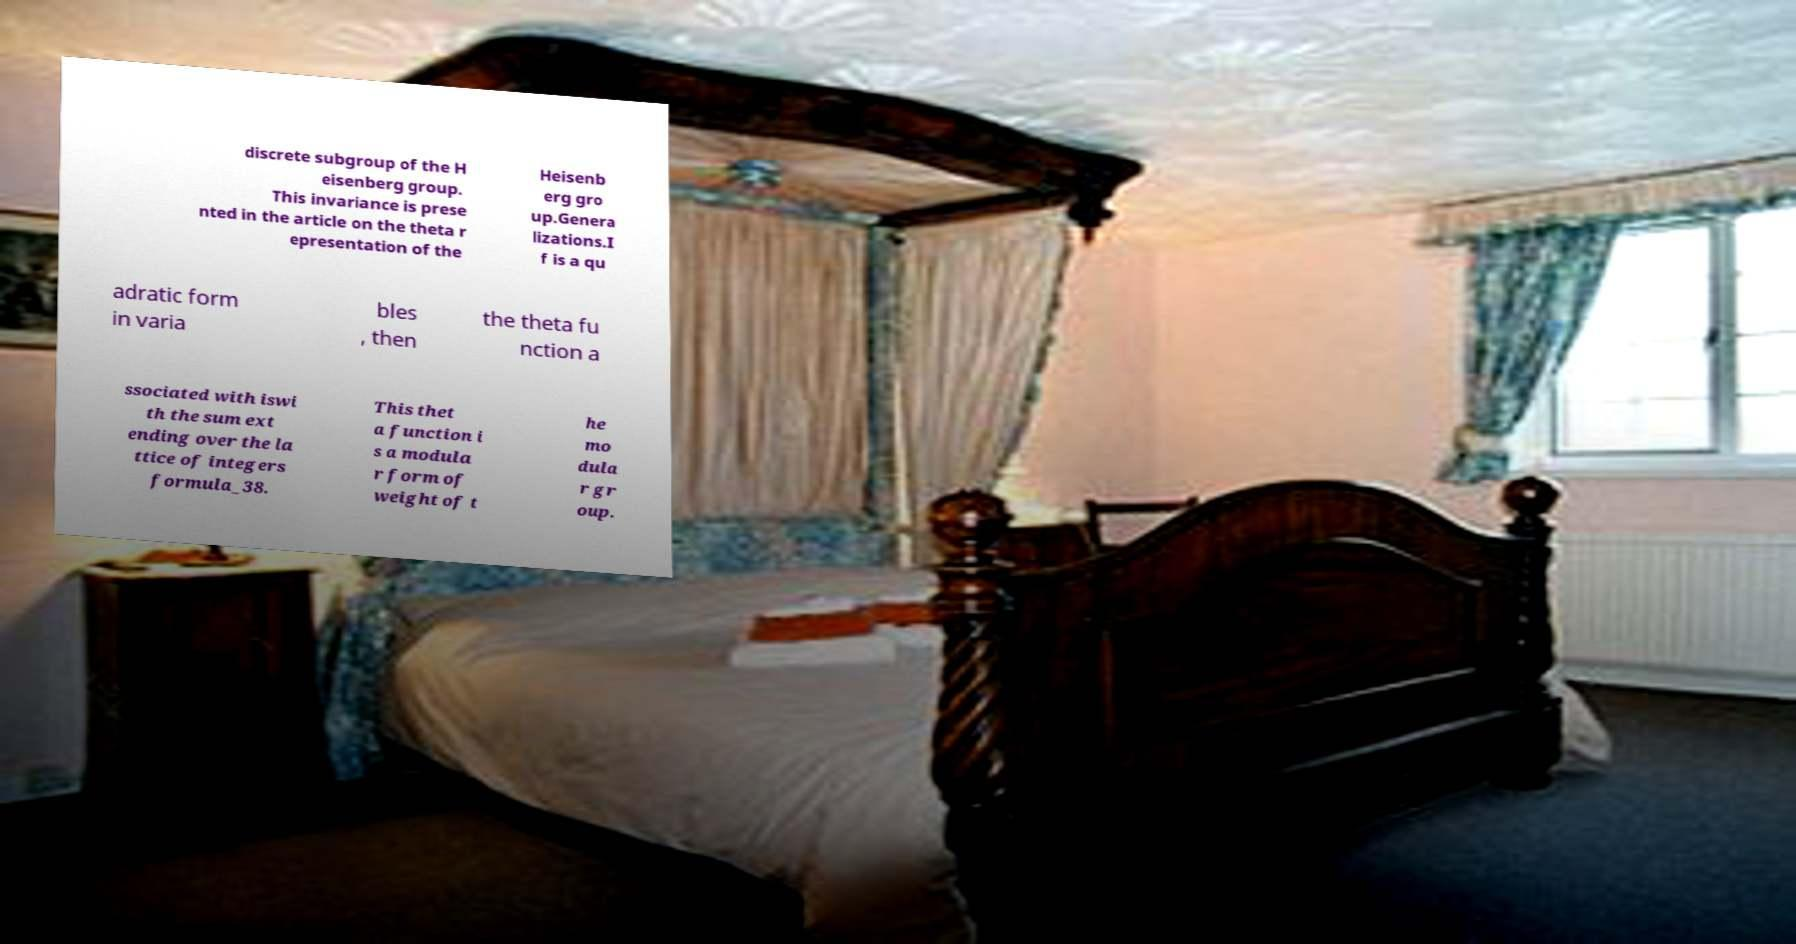Please identify and transcribe the text found in this image. discrete subgroup of the H eisenberg group. This invariance is prese nted in the article on the theta r epresentation of the Heisenb erg gro up.Genera lizations.I f is a qu adratic form in varia bles , then the theta fu nction a ssociated with iswi th the sum ext ending over the la ttice of integers formula_38. This thet a function i s a modula r form of weight of t he mo dula r gr oup. 